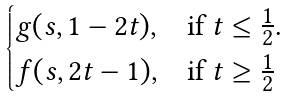Convert formula to latex. <formula><loc_0><loc_0><loc_500><loc_500>\begin{cases} g ( s , 1 - 2 t ) , & \text {if $t \leq \frac{1}{2}$.} \\ f ( s , 2 t - 1 ) , & \text {if $t \geq \frac{1}{2}$} \end{cases}</formula> 